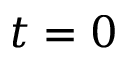<formula> <loc_0><loc_0><loc_500><loc_500>t = 0</formula> 